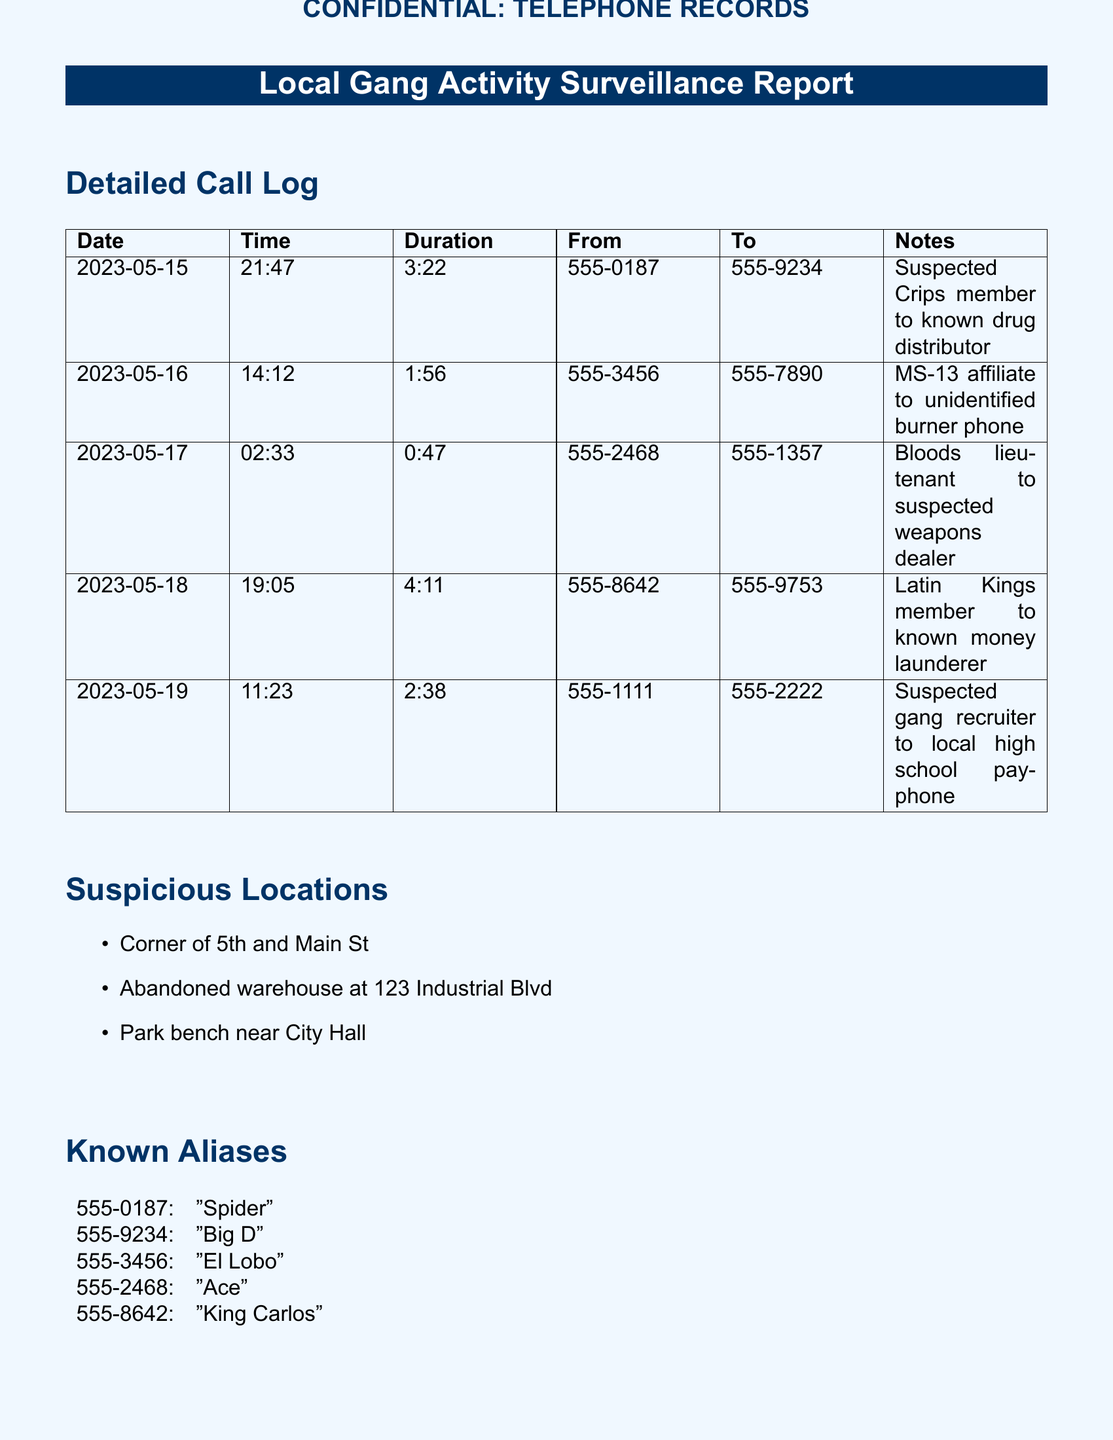what was the duration of the call on 2023-05-17? The duration of the call on this date was 0:47.
Answer: 0:47 who is associated with the phone number 555-3456? The alias associated with this phone number is "El Lobo".
Answer: El Lobo what is the observed activity at the abandoned warehouse? There has been increased activity observed around the abandoned warehouse.
Answer: Increased activity which gang is linked to the call from 555-8642? The call from this number is linked to a Latin Kings member.
Answer: Latin Kings what location is mentioned as suspicious for gang activity? The corner of 5th and Main St is mentioned as a suspicious location.
Answer: Corner of 5th and Main St how many minutes long was the call on 2023-05-18? The call on this date lasted 4:11, which is 251 minutes.
Answer: 4:11 who was the suspected gang recruiter in the call log? The suspected gang recruiter's number is 555-1111.
Answer: 555-1111 which gang member was connected to a known drug distributor? The call was made by a suspected Crips member.
Answer: Suspected Crips member 